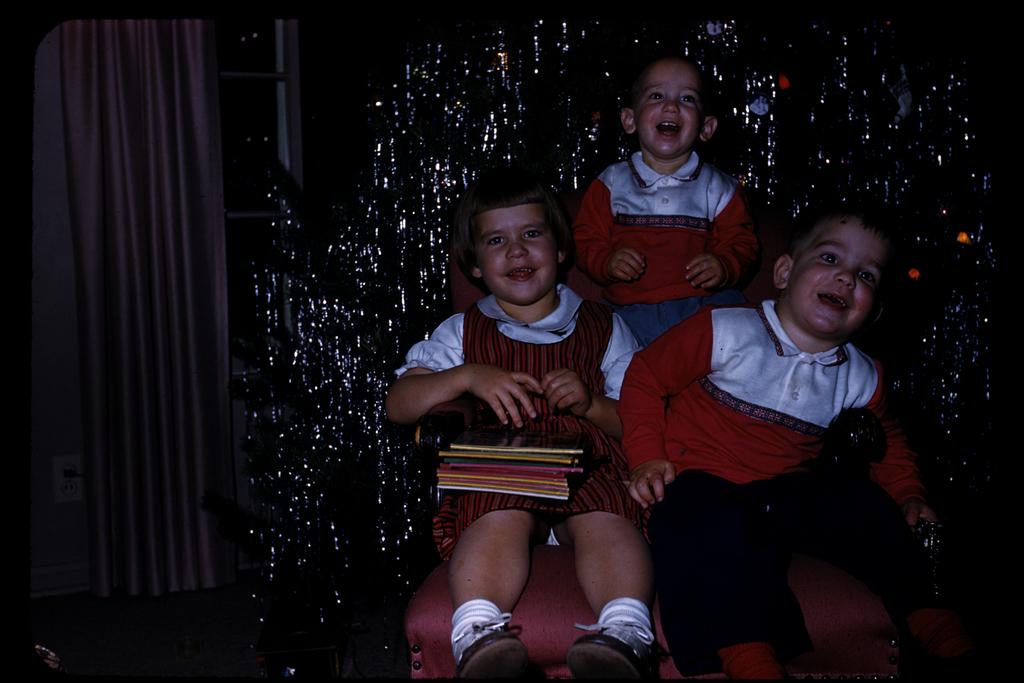How many children are in the image? There are three children in the image. Where are the children located? The children are on a couch. What is on one of the children? There are objects on one of the children. What type of window treatment is visible in the image? There is a curtain visible in the image. What colors are present in the background of the image? The background of the image is white and black in color. What type of tent can be seen in the background of the image? There is no tent present in the image; the background is white and black in color. 